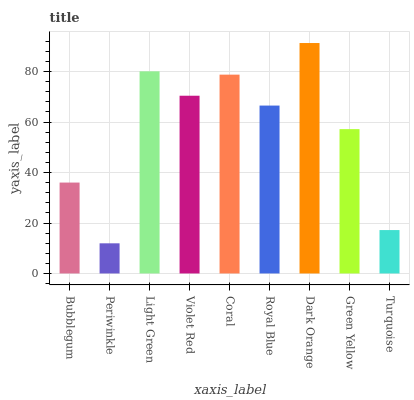Is Periwinkle the minimum?
Answer yes or no. Yes. Is Dark Orange the maximum?
Answer yes or no. Yes. Is Light Green the minimum?
Answer yes or no. No. Is Light Green the maximum?
Answer yes or no. No. Is Light Green greater than Periwinkle?
Answer yes or no. Yes. Is Periwinkle less than Light Green?
Answer yes or no. Yes. Is Periwinkle greater than Light Green?
Answer yes or no. No. Is Light Green less than Periwinkle?
Answer yes or no. No. Is Royal Blue the high median?
Answer yes or no. Yes. Is Royal Blue the low median?
Answer yes or no. Yes. Is Periwinkle the high median?
Answer yes or no. No. Is Green Yellow the low median?
Answer yes or no. No. 